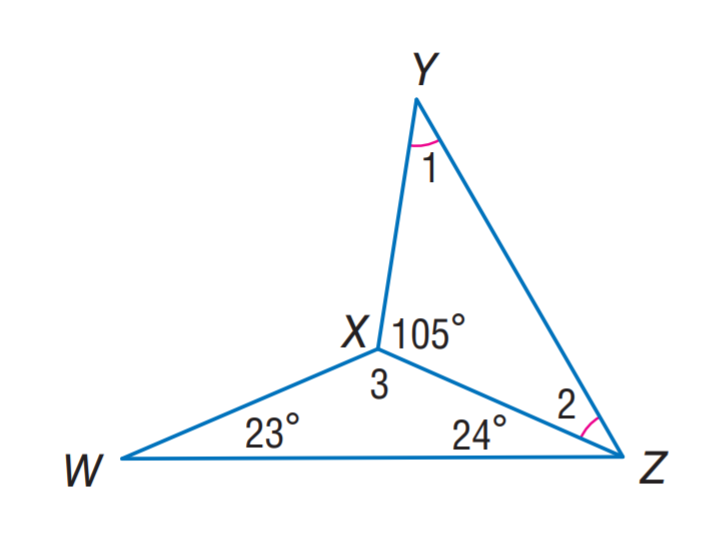Answer the mathemtical geometry problem and directly provide the correct option letter.
Question: Find m \angle 3.
Choices: A: 37.5 B: 52.5 C: 105 D: 133 D 